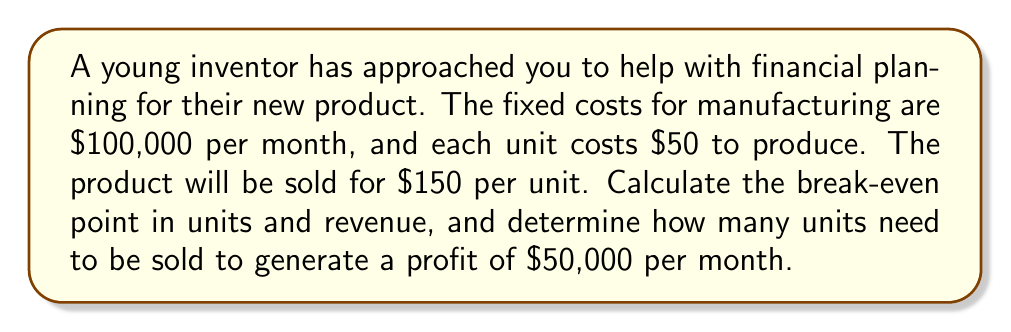Teach me how to tackle this problem. Let's approach this step-by-step:

1. Define variables:
   $FC$ = Fixed Costs = $100,000
   $VC$ = Variable Cost per unit = $50
   $P$ = Price per unit = $150

2. Calculate Contribution Margin (CM) per unit:
   $CM = P - VC = 150 - 50 = $100$ per unit

3. Calculate Break-even point in units:
   $$BE_{units} = \frac{FC}{CM} = \frac{100,000}{100} = 1,000 \text{ units}$$

4. Calculate Break-even point in revenue:
   $$BE_{revenue} = BE_{units} \times P = 1,000 \times 150 = $150,000$$

5. To find units needed for $50,000 profit:
   Let $x$ be the number of units
   $$Revenue - Total Costs = Profit$$
   $$150x - (100,000 + 50x) = 50,000$$
   $$150x - 100,000 - 50x = 50,000$$
   $$100x = 150,000$$
   $$x = 1,500 \text{ units}$$

Therefore, 1,500 units need to be sold to generate a profit of $50,000 per month.
Answer: Break-even point: 1,000 units or $150,000 revenue. For $50,000 profit: 1,500 units. 